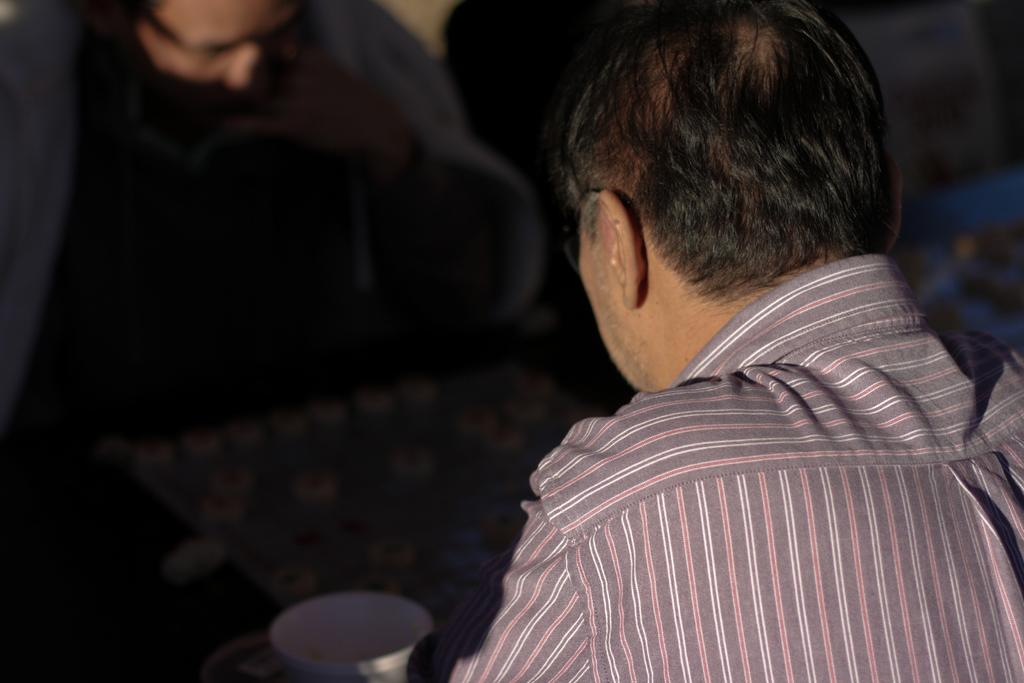Who is present in the image? There is a man in the image. What is the man wearing? The man is wearing a shirt. What object can be seen in the image besides the man? There is a cup in the image. Can you describe the background of the image? The background of the image is a bit dark. Are there any other people visible in the image? Yes, there is another person in the background of the image. What type of boat can be seen in the image? There is no boat present in the image. How many toes are visible on the man's feet in the image? The image does not show the man's feet, so it is not possible to determine the number of toes visible. 